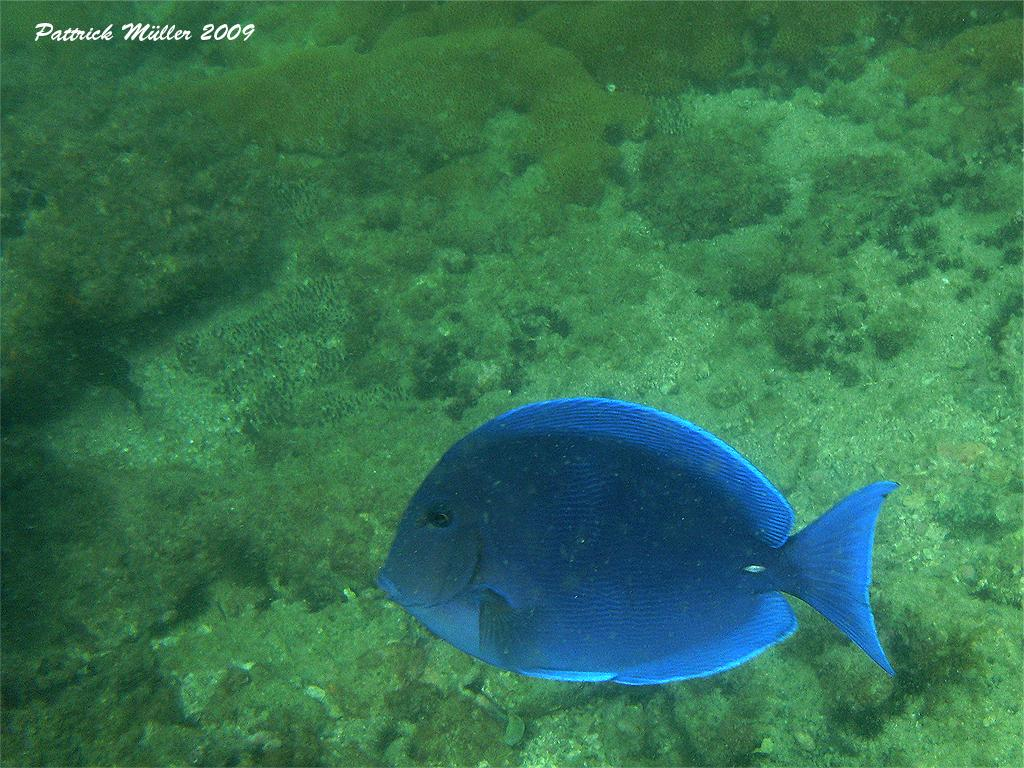What type of animal is in the image? There is a blue color fish in the image. What color is the background of the image? The background of the image is green. Is there any additional mark or feature in the image? Yes, there is a watermark in the image. What type of whistle can be heard coming from the fish in the image? There is no whistle present in the image, as fish do not make whistling sounds. 